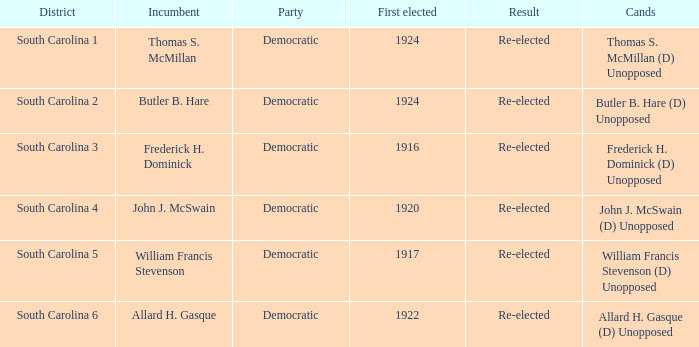Who is the candidate in district south carolina 2? Butler B. Hare (D) Unopposed. 